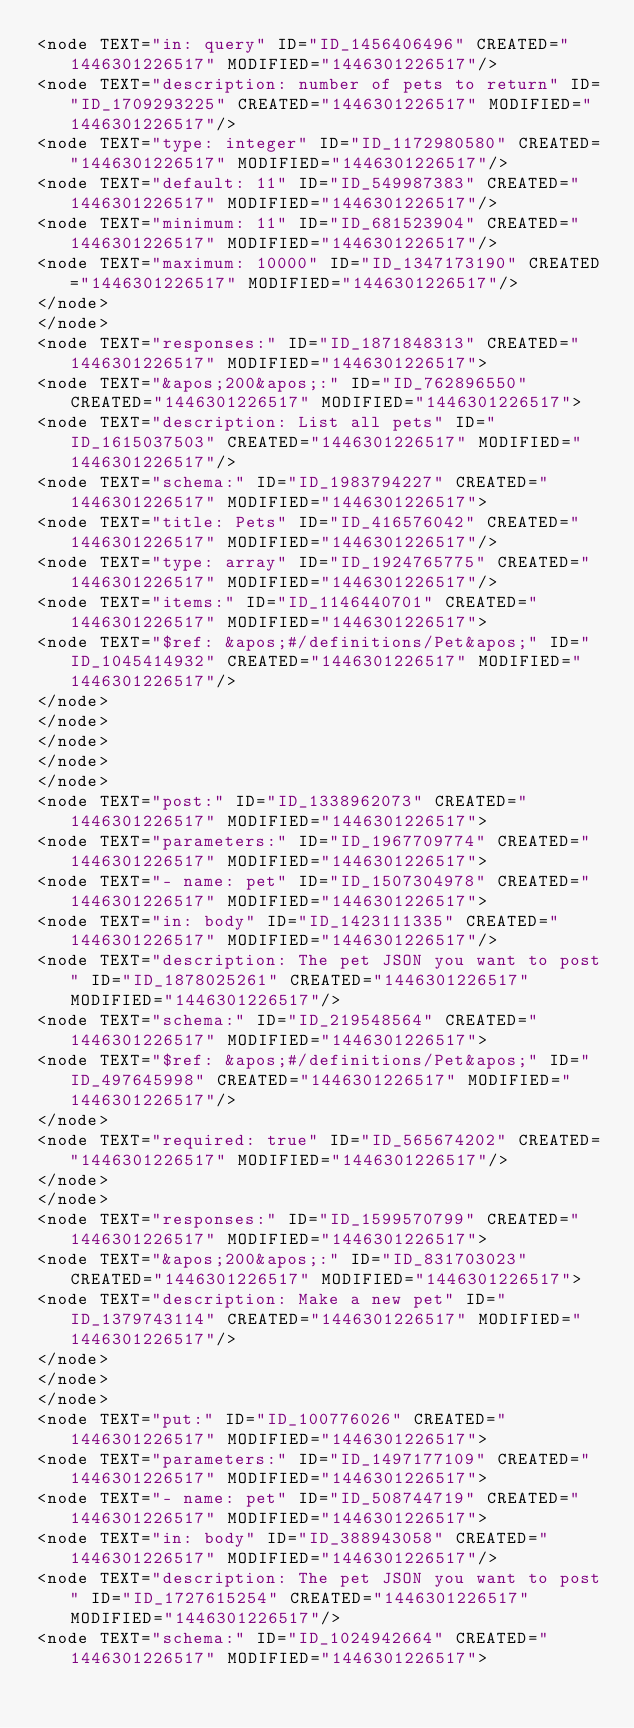Convert code to text. <code><loc_0><loc_0><loc_500><loc_500><_ObjectiveC_><node TEXT="in: query" ID="ID_1456406496" CREATED="1446301226517" MODIFIED="1446301226517"/>
<node TEXT="description: number of pets to return" ID="ID_1709293225" CREATED="1446301226517" MODIFIED="1446301226517"/>
<node TEXT="type: integer" ID="ID_1172980580" CREATED="1446301226517" MODIFIED="1446301226517"/>
<node TEXT="default: 11" ID="ID_549987383" CREATED="1446301226517" MODIFIED="1446301226517"/>
<node TEXT="minimum: 11" ID="ID_681523904" CREATED="1446301226517" MODIFIED="1446301226517"/>
<node TEXT="maximum: 10000" ID="ID_1347173190" CREATED="1446301226517" MODIFIED="1446301226517"/>
</node>
</node>
<node TEXT="responses:" ID="ID_1871848313" CREATED="1446301226517" MODIFIED="1446301226517">
<node TEXT="&apos;200&apos;:" ID="ID_762896550" CREATED="1446301226517" MODIFIED="1446301226517">
<node TEXT="description: List all pets" ID="ID_1615037503" CREATED="1446301226517" MODIFIED="1446301226517"/>
<node TEXT="schema:" ID="ID_1983794227" CREATED="1446301226517" MODIFIED="1446301226517">
<node TEXT="title: Pets" ID="ID_416576042" CREATED="1446301226517" MODIFIED="1446301226517"/>
<node TEXT="type: array" ID="ID_1924765775" CREATED="1446301226517" MODIFIED="1446301226517"/>
<node TEXT="items:" ID="ID_1146440701" CREATED="1446301226517" MODIFIED="1446301226517">
<node TEXT="$ref: &apos;#/definitions/Pet&apos;" ID="ID_1045414932" CREATED="1446301226517" MODIFIED="1446301226517"/>
</node>
</node>
</node>
</node>
</node>
<node TEXT="post:" ID="ID_1338962073" CREATED="1446301226517" MODIFIED="1446301226517">
<node TEXT="parameters:" ID="ID_1967709774" CREATED="1446301226517" MODIFIED="1446301226517">
<node TEXT="- name: pet" ID="ID_1507304978" CREATED="1446301226517" MODIFIED="1446301226517">
<node TEXT="in: body" ID="ID_1423111335" CREATED="1446301226517" MODIFIED="1446301226517"/>
<node TEXT="description: The pet JSON you want to post" ID="ID_1878025261" CREATED="1446301226517" MODIFIED="1446301226517"/>
<node TEXT="schema:" ID="ID_219548564" CREATED="1446301226517" MODIFIED="1446301226517">
<node TEXT="$ref: &apos;#/definitions/Pet&apos;" ID="ID_497645998" CREATED="1446301226517" MODIFIED="1446301226517"/>
</node>
<node TEXT="required: true" ID="ID_565674202" CREATED="1446301226517" MODIFIED="1446301226517"/>
</node>
</node>
<node TEXT="responses:" ID="ID_1599570799" CREATED="1446301226517" MODIFIED="1446301226517">
<node TEXT="&apos;200&apos;:" ID="ID_831703023" CREATED="1446301226517" MODIFIED="1446301226517">
<node TEXT="description: Make a new pet" ID="ID_1379743114" CREATED="1446301226517" MODIFIED="1446301226517"/>
</node>
</node>
</node>
<node TEXT="put:" ID="ID_100776026" CREATED="1446301226517" MODIFIED="1446301226517">
<node TEXT="parameters:" ID="ID_1497177109" CREATED="1446301226517" MODIFIED="1446301226517">
<node TEXT="- name: pet" ID="ID_508744719" CREATED="1446301226517" MODIFIED="1446301226517">
<node TEXT="in: body" ID="ID_388943058" CREATED="1446301226517" MODIFIED="1446301226517"/>
<node TEXT="description: The pet JSON you want to post" ID="ID_1727615254" CREATED="1446301226517" MODIFIED="1446301226517"/>
<node TEXT="schema:" ID="ID_1024942664" CREATED="1446301226517" MODIFIED="1446301226517"></code> 